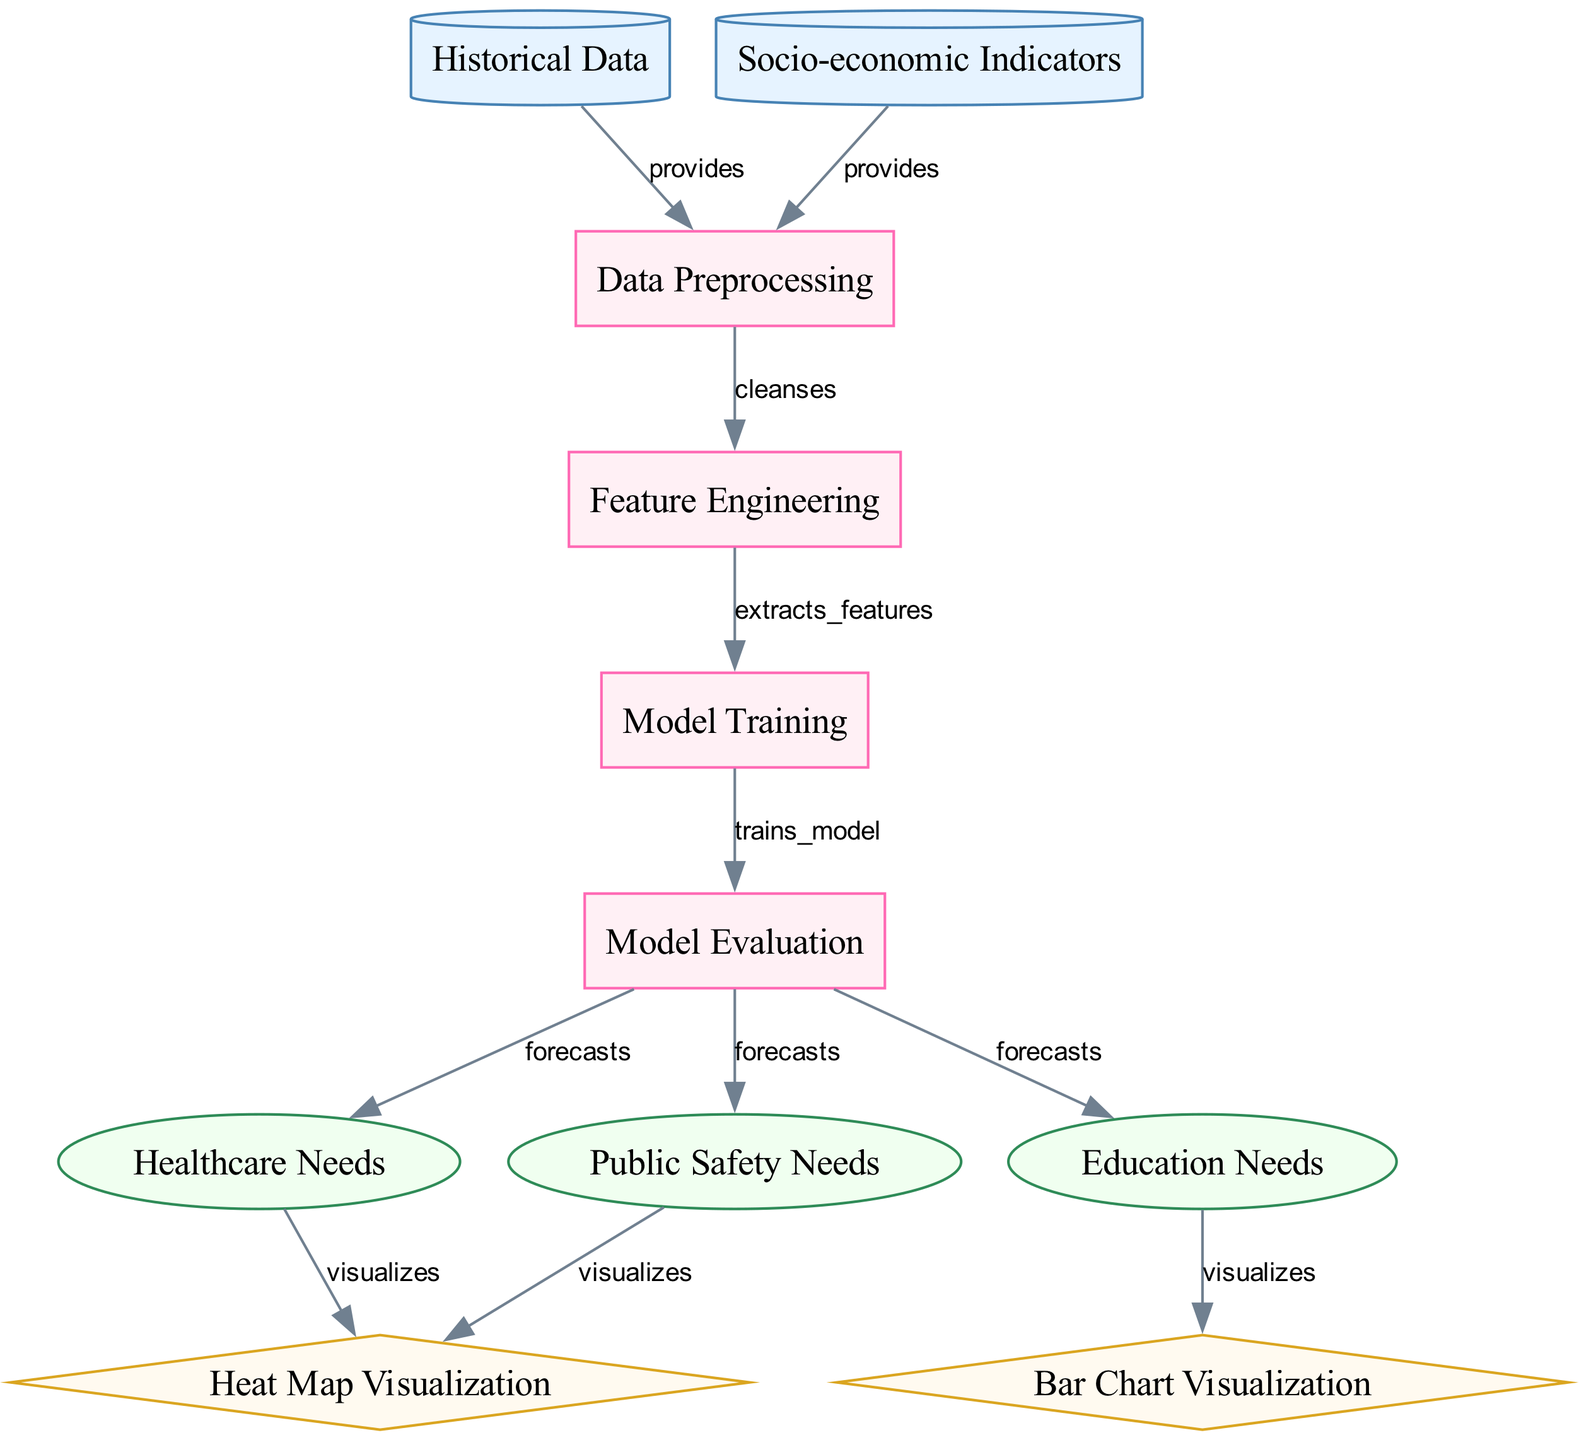What types of data are provided to the data preprocessing step? The diagram shows two nodes: "Historical Data" and "Socio-economic Indicators," both of which point to "Data Preprocessing" with the label "provides." This indicates that these two data types are used as inputs for data preprocessing.
Answer: Historical Data, Socio-economic Indicators How many output nodes are there in the diagram? The diagram displays three output nodes: "Healthcare Needs," "Education Needs," and "Public Safety Needs." Hence, the count of these distinct output nodes gives us the answer.
Answer: 3 What is the first process that occurs after data preprocessing? The diagram shows that the "Data Preprocessing" node connects to the "Feature Engineering" node, indicating that feature engineering is the first process that follows data preprocessing.
Answer: Feature Engineering Which output is visualized using a bar chart? The "Education Needs" node connects to the "Bar Chart Visualization," indicating that this particular output is visualized as a bar chart in the diagram.
Answer: Education Needs Which node forecasts public safety needs? The node "Public Safety Needs" receives its forecast from the "Model Evaluation" node, which is indicated by the "forecasts" label on the arrow connecting these two nodes.
Answer: Model Evaluation What type of visualization is used for healthcare needs? The diagram indicates that "Healthcare Needs" is connected to "Heat Map Visualization," which shows that a heat map visualization is used for this output.
Answer: Heat Map Visualization Which process happens after model training? According to the diagram, "Model Training" is followed by "Model Evaluation," as indicated by the directional edge labeled "trains_model." This shows the flow of processes in the model lifecycle.
Answer: Model Evaluation How many edges connect to public safety needs? Upon examining the diagram, "Public Safety Needs" has one incoming edge from the "Model Evaluation" node, and one outgoing edge going to the "Heat Map Visualization." Therefore, the total number of edges concerning this node is calculated.
Answer: 2 